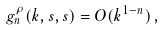Convert formula to latex. <formula><loc_0><loc_0><loc_500><loc_500>g ^ { \rho } _ { n } ( k , s , s ) = O ( k ^ { 1 - n } ) \, ,</formula> 